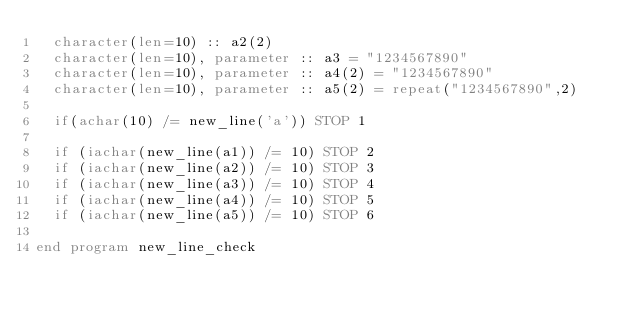Convert code to text. <code><loc_0><loc_0><loc_500><loc_500><_FORTRAN_>  character(len=10) :: a2(2)
  character(len=10), parameter :: a3 = "1234567890"
  character(len=10), parameter :: a4(2) = "1234567890"
  character(len=10), parameter :: a5(2) = repeat("1234567890",2)

  if(achar(10) /= new_line('a')) STOP 1

  if (iachar(new_line(a1)) /= 10) STOP 2
  if (iachar(new_line(a2)) /= 10) STOP 3
  if (iachar(new_line(a3)) /= 10) STOP 4
  if (iachar(new_line(a4)) /= 10) STOP 5
  if (iachar(new_line(a5)) /= 10) STOP 6

end program new_line_check
</code> 